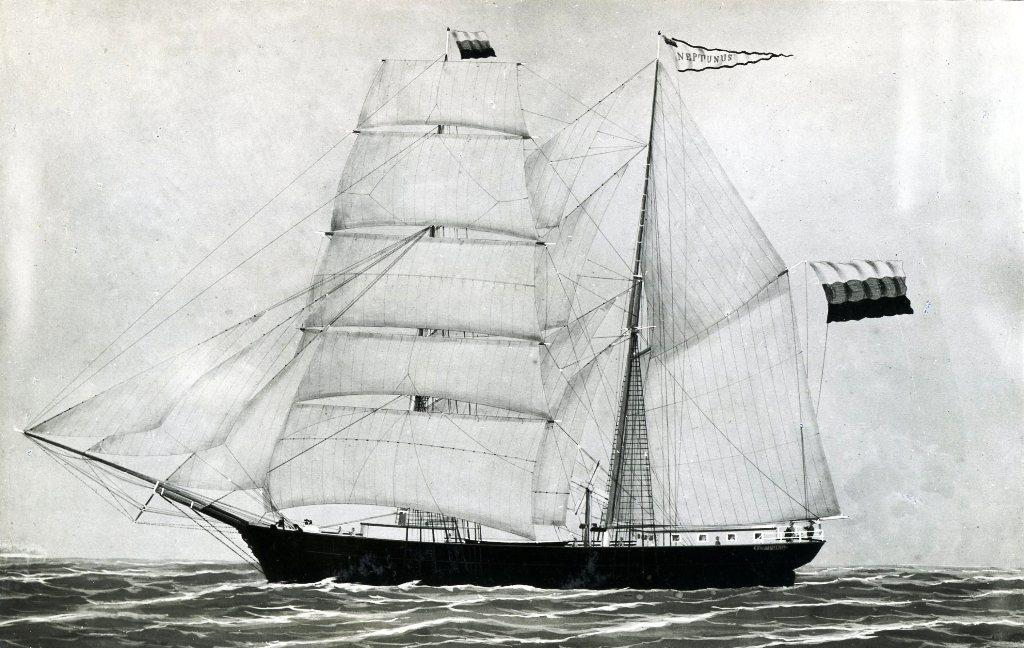What is the color scheme of the image? The image is black and white. What can be seen in the water in the image? There is a ship in the water. Does the ship have any distinguishing features? Yes, the ship has a flag. What else is visible in the image besides the ship? The sky is visible in the image. What type of nut is being used as a prop for the event in the image? There is no nut or event present in the image; it features a black and white image of a ship in the water with a visible flag and sky. 